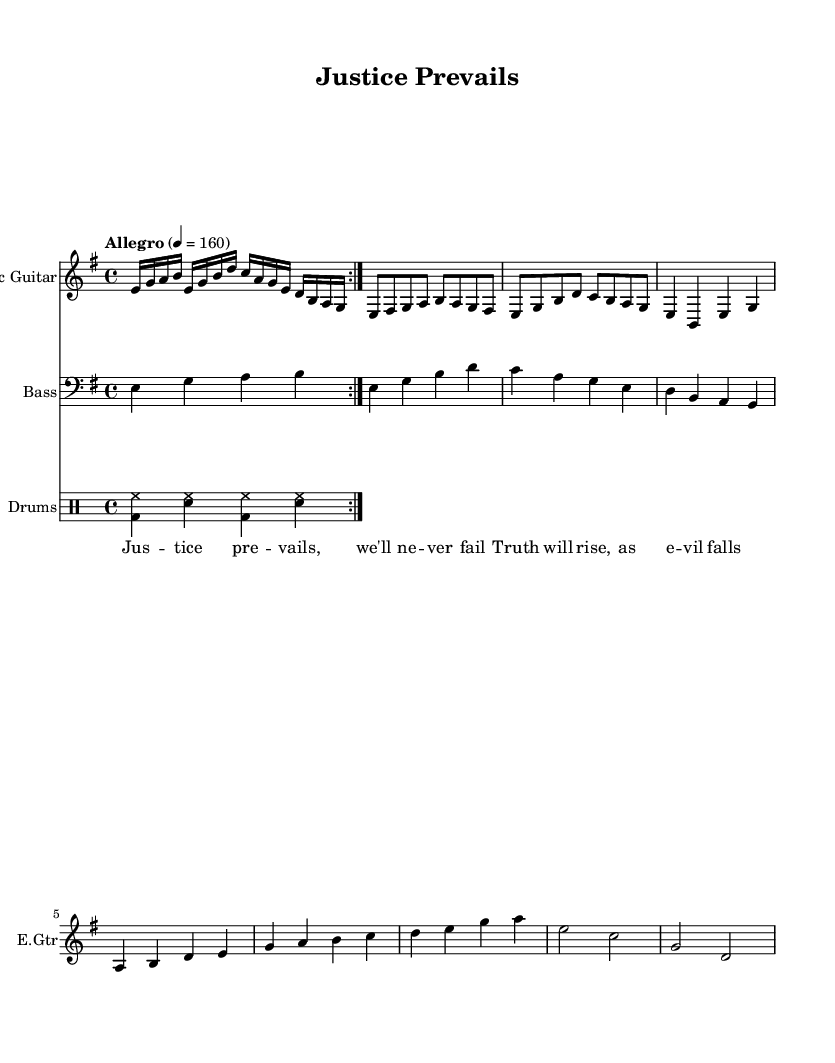What is the key signature of this music? The key signature is E minor, which contains one sharp (F#). It can be identified by the 1 sharp shown in the key signature section of the sheet music.
Answer: E minor What is the time signature of this music? The time signature is 4/4, commonly known as "four-four time." It indicates that there are four beats in each measure, which is clearly marked at the beginning of the score.
Answer: 4/4 What is the tempo marking for this piece? The tempo marking is "Allegro," indicating a fast and lively pace. The specific speed is indicated by the metronome marking of 160 beats per minute, which can be found at the start of the score.
Answer: Allegro How many sections are in the main structure of the piece? The piece consists of four main sections: Intro, Verse, Chorus, and Bridge. Each section is defined by different musical phrases and varies in their content, indicated in the sheet music.
Answer: Four What type of vocals are indicated in this music? The lyrics are intended for added vocal lines that emphasize a celebratory and triumphant theme, which aligns with the power metal genre. The specific lyrics capture themes of justice and truth.
Answer: Lyrics Which instrument plays the main riff in this piece? The Electric Guitar is primarily responsible for playing the main riff, which is repeated in the intro. It is clearly indicated by the instrument name at the beginning of the staff and the repetition of the musical notes.
Answer: Electric Guitar What rhythm pattern is used in the drums? The rhythm pattern features a basic rock beat, characterized by the bass drum (bd) and hi-hat (hh) combination, with snare (sn) accents. This pattern is common and defines the drumming style in this kind of music.
Answer: Basic rock beat 